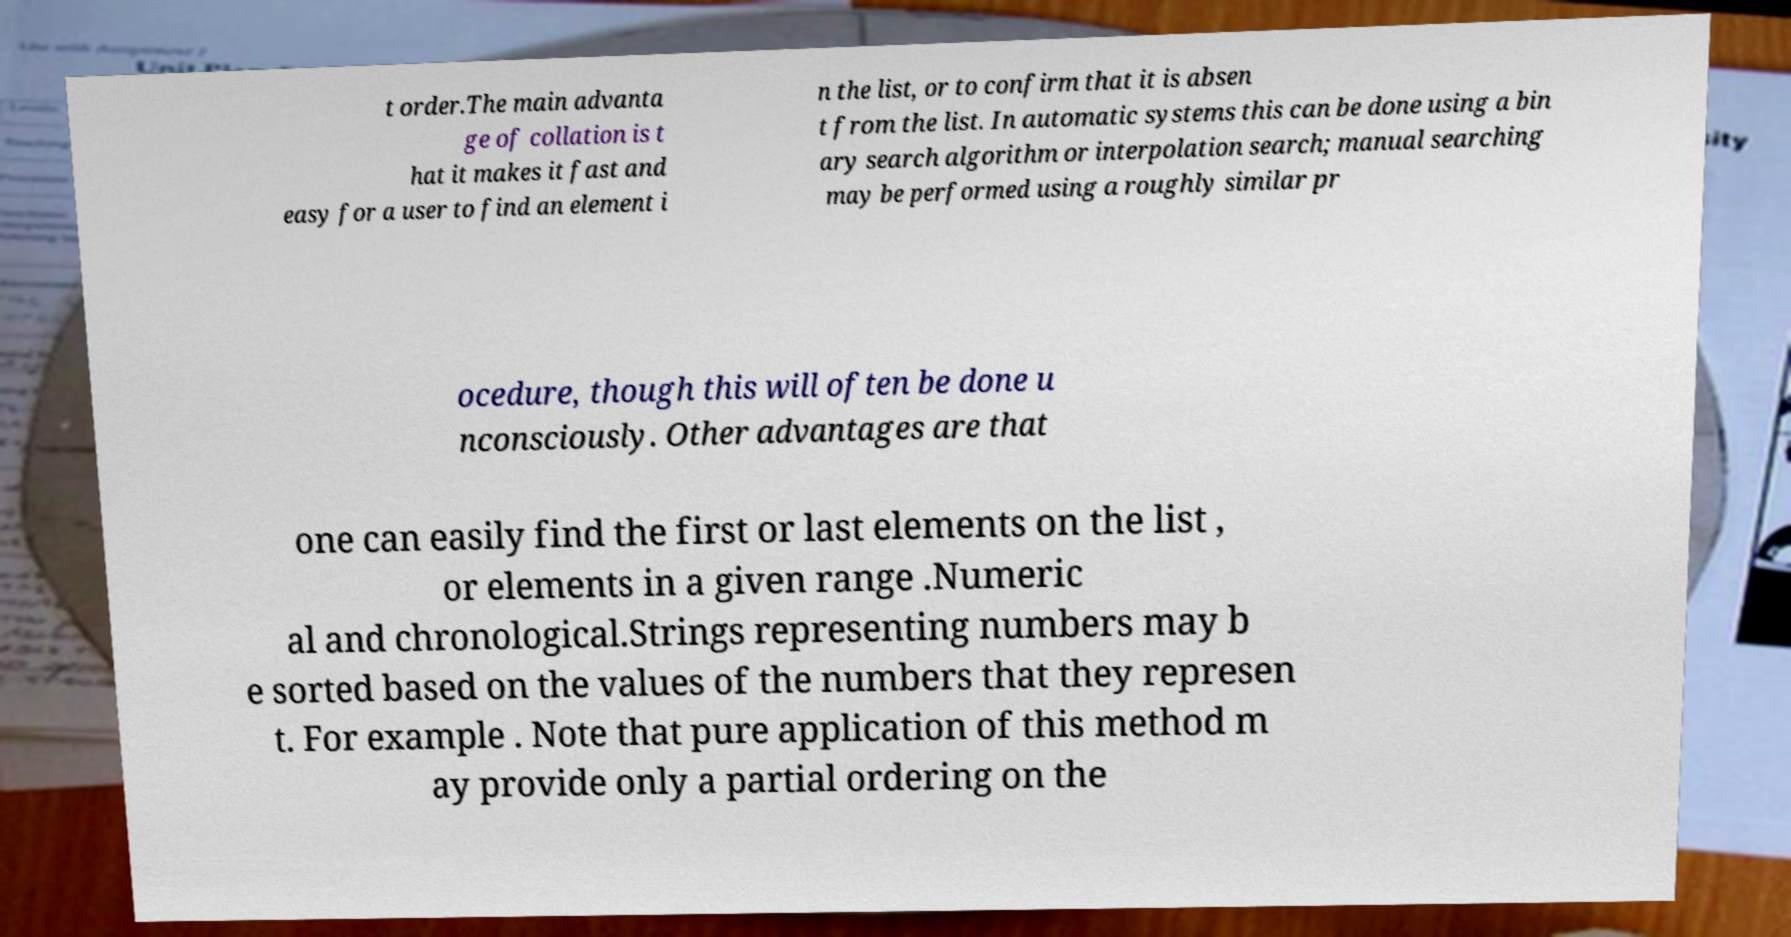There's text embedded in this image that I need extracted. Can you transcribe it verbatim? t order.The main advanta ge of collation is t hat it makes it fast and easy for a user to find an element i n the list, or to confirm that it is absen t from the list. In automatic systems this can be done using a bin ary search algorithm or interpolation search; manual searching may be performed using a roughly similar pr ocedure, though this will often be done u nconsciously. Other advantages are that one can easily find the first or last elements on the list , or elements in a given range .Numeric al and chronological.Strings representing numbers may b e sorted based on the values of the numbers that they represen t. For example . Note that pure application of this method m ay provide only a partial ordering on the 